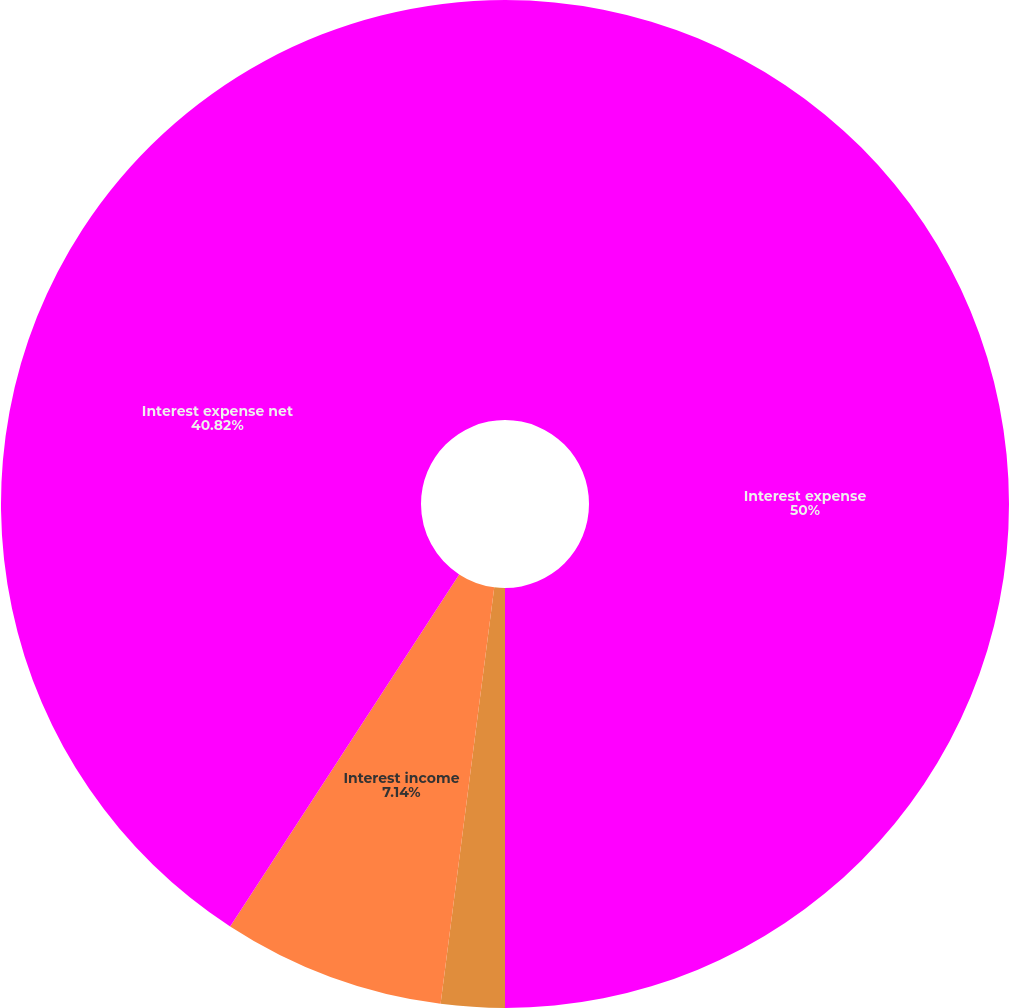Convert chart. <chart><loc_0><loc_0><loc_500><loc_500><pie_chart><fcel>Interest expense<fcel>Capitalized interest<fcel>Interest income<fcel>Interest expense net<nl><fcel>50.0%<fcel>2.04%<fcel>7.14%<fcel>40.82%<nl></chart> 